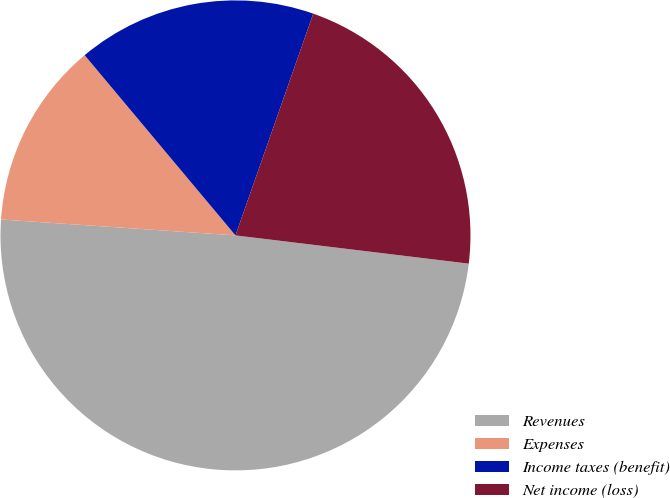<chart> <loc_0><loc_0><loc_500><loc_500><pie_chart><fcel>Revenues<fcel>Expenses<fcel>Income taxes (benefit)<fcel>Net income (loss)<nl><fcel>49.16%<fcel>12.83%<fcel>16.46%<fcel>21.55%<nl></chart> 